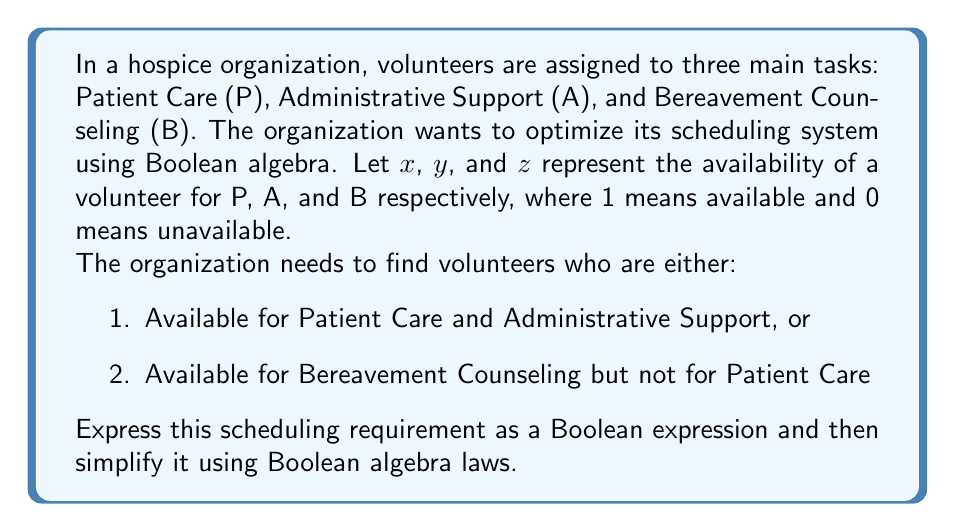Can you answer this question? Let's approach this step-by-step:

1) First, let's express each condition in Boolean algebra:
   - Condition 1: Available for P and A = $x \cdot y$
   - Condition 2: Available for B but not P = $\bar{x} \cdot z$

2) The organization needs volunteers who satisfy either condition, so we use the OR operator:
   $$(x \cdot y) + (\bar{x} \cdot z)$$

3) This is our initial Boolean expression. Now, let's simplify it using Boolean algebra laws:

4) We can use the distributive law: $a + (b \cdot c) = (a + b) \cdot (a + c)$
   $$(x \cdot y) + (\bar{x} \cdot z) = (x + \bar{x}) \cdot (x + z) \cdot (y + \bar{x}) \cdot (y + z)$$

5) Simplify using the complement law: $x + \bar{x} = 1$
   $$= 1 \cdot (x + z) \cdot (y + \bar{x}) \cdot (y + z)$$

6) Simplify by removing the 1:
   $$= (x + z) \cdot (y + \bar{x}) \cdot (y + z)$$

7) This is the simplified Boolean expression representing the scheduling requirement.
Answer: $(x + z) \cdot (y + \bar{x}) \cdot (y + z)$ 